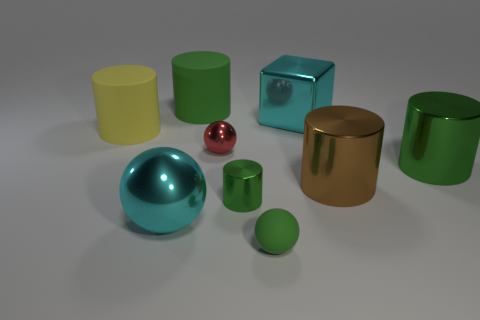How many green cylinders must be subtracted to get 1 green cylinders? 2 Subtract all large yellow cylinders. How many cylinders are left? 4 Subtract all green cylinders. How many cylinders are left? 2 Subtract all blocks. How many objects are left? 8 Subtract 0 purple cylinders. How many objects are left? 9 Subtract 2 cylinders. How many cylinders are left? 3 Subtract all yellow spheres. Subtract all yellow cylinders. How many spheres are left? 3 Subtract all blue cubes. How many blue balls are left? 0 Subtract all small cyan cylinders. Subtract all shiny blocks. How many objects are left? 8 Add 8 brown metallic objects. How many brown metallic objects are left? 9 